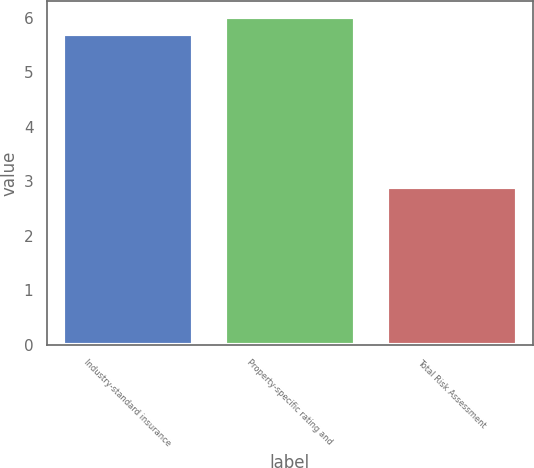Convert chart. <chart><loc_0><loc_0><loc_500><loc_500><bar_chart><fcel>Industry-standard insurance<fcel>Property-specific rating and<fcel>Total Risk Assessment<nl><fcel>5.7<fcel>6.01<fcel>2.9<nl></chart> 